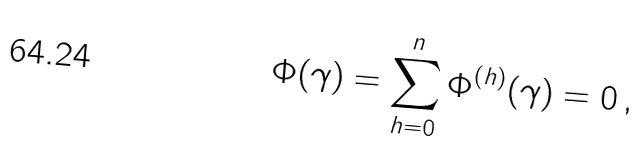<formula> <loc_0><loc_0><loc_500><loc_500>\Phi ( \gamma ) = \sum _ { h = 0 } ^ { n } { \Phi ^ { ( h ) } ( \gamma ) } = 0 \, ,</formula> 